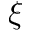<formula> <loc_0><loc_0><loc_500><loc_500>\xi</formula> 